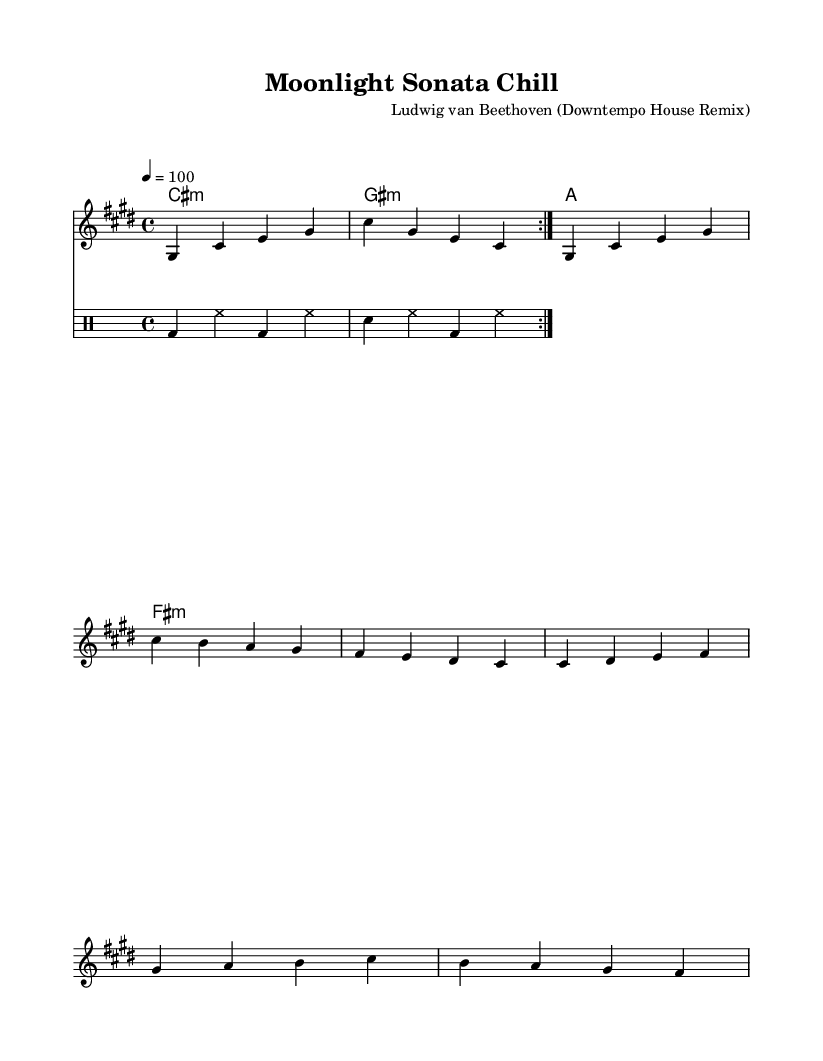What is the key signature of this music? The key signature in the music indicates C sharp minor, which is represented by four sharps (F sharp, C sharp, G sharp, and D sharp). This can be identified in the area of the staff where the key signature is noted at the beginning.
Answer: C sharp minor What is the time signature of this piece? The time signature is shown as 4/4, which means there are four beats in each measure, and the quarter note gets one beat. This is located at the start of the piece just after the key signature.
Answer: 4/4 What is the tempo marking indicated? The tempo marking is 100 beats per minute, specified as "4 = 100," indicating how fast the piece should be played. This is generally found near the beginning of the sheet music under the global settings.
Answer: 100 How many measures are in the chorus section? To find the number of measures in the chorus, we look at the portion of the score designated as the chorus, where there are four measures presented. Counting the measures in that section reveals the total.
Answer: 4 What is the first chord in the harmony section? The first chord indicated in the harmony section is a C sharp minor chord, which is noted as "cis:m" in the chord mode. This can be seen at the beginning of the harmony part within the staff.
Answer: C sharp minor What rhythmic element is primarily used in the drum part? The rhythmic element used prominently in the drum part is the bass drum, represented by "bd," which appears in the repeated pattern throughout the drum staff. This is raised in the context of the notation to highlight its prevalence.
Answer: Bass drum What is the highest note of the melody in the first verse? The highest note in the melody section of the first verse is G sharp, which is present in the melody line and can be found by identifying the notes in that specific section of the score.
Answer: G sharp 